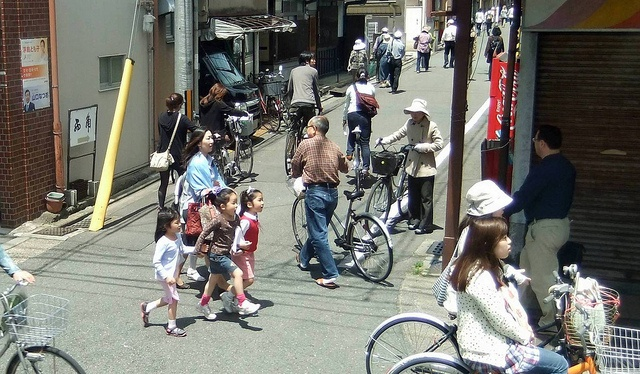Describe the objects in this image and their specific colors. I can see people in brown, darkgray, black, gray, and lightgray tones, people in brown, white, darkgray, black, and gray tones, people in brown, black, gray, and maroon tones, bicycle in brown, darkgray, lightgray, gray, and black tones, and people in brown, black, gray, blue, and darkgray tones in this image. 